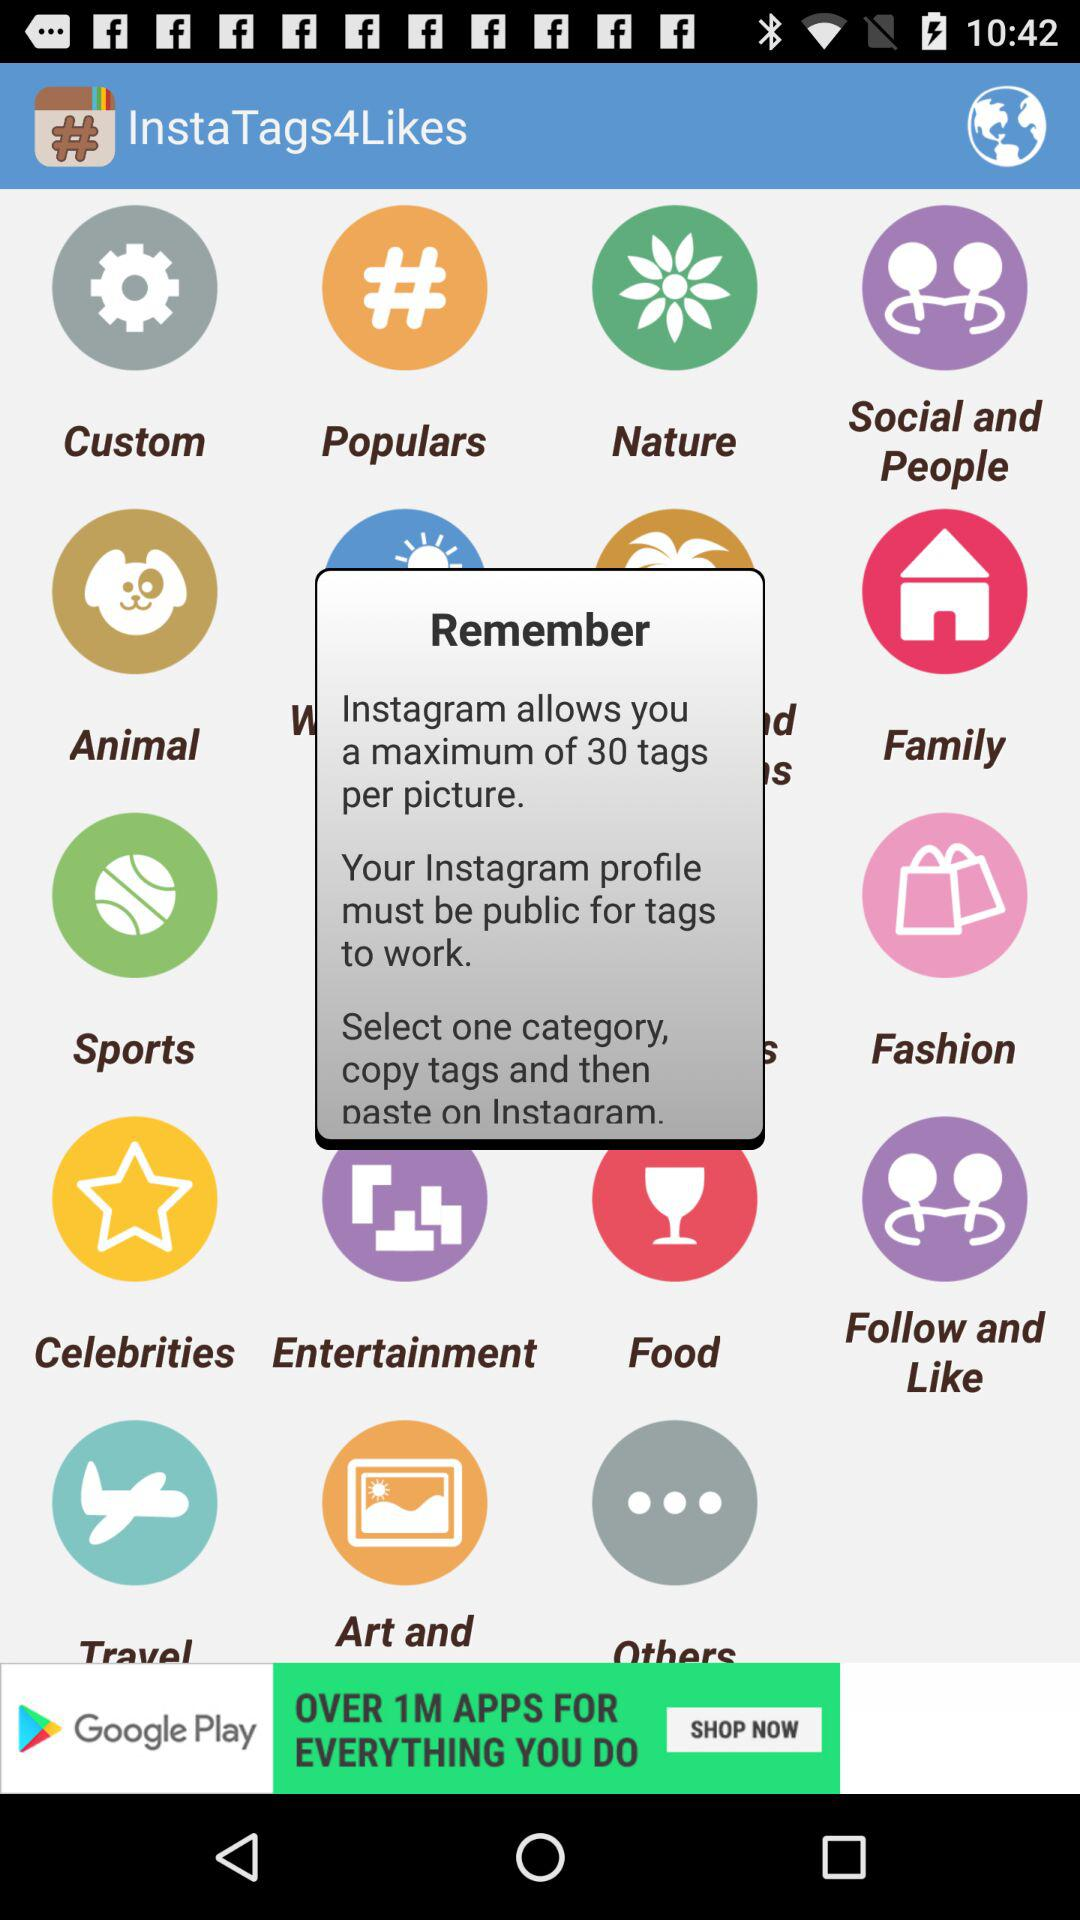What is the application name? The application name is "InstaTags4Likes". 